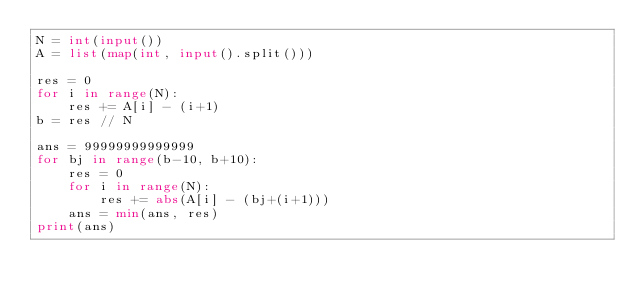<code> <loc_0><loc_0><loc_500><loc_500><_Python_>N = int(input())
A = list(map(int, input().split()))

res = 0
for i in range(N):
    res += A[i] - (i+1)
b = res // N

ans = 99999999999999
for bj in range(b-10, b+10):
    res = 0
    for i in range(N):
        res += abs(A[i] - (bj+(i+1)))
    ans = min(ans, res)
print(ans)
</code> 